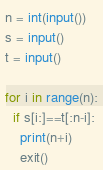<code> <loc_0><loc_0><loc_500><loc_500><_Python_>n = int(input())
s = input()
t = input()

for i in range(n):
  if s[i:]==t[:n-i]:
    print(n+i)
    exit()
</code> 